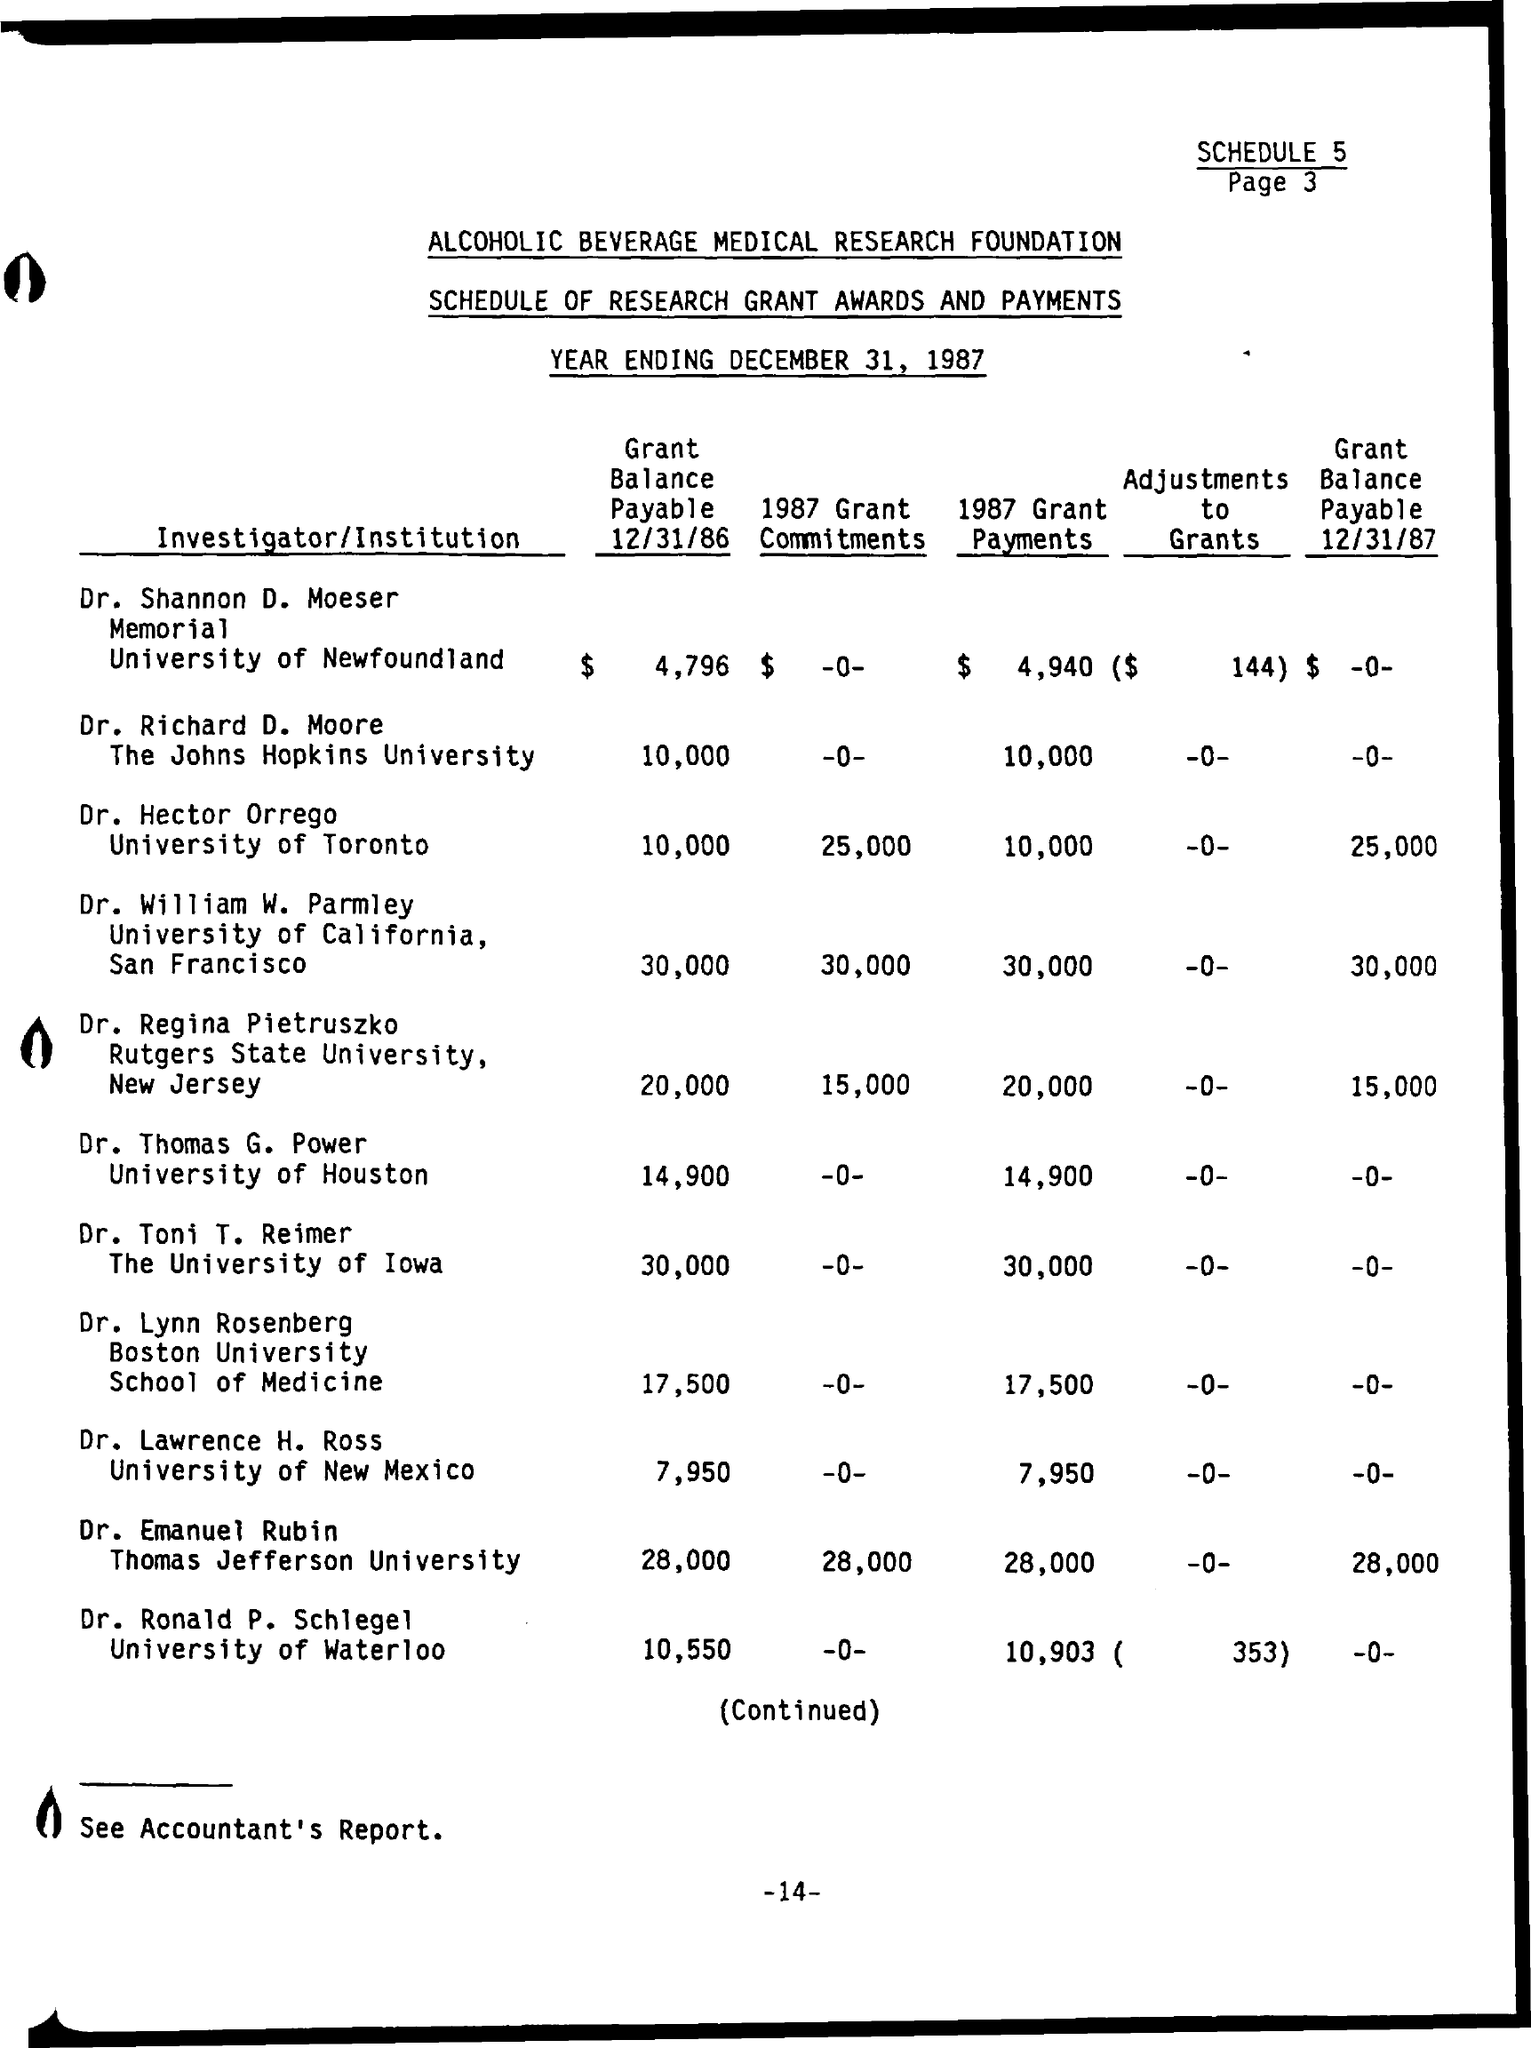Specify some key components in this picture. The theme of the "Schedule of Research Grant Awards and Payments" is to provide a schedule for the awards and payments of research grants. The investigator at the University of California is Dr. William W. Parmley. 